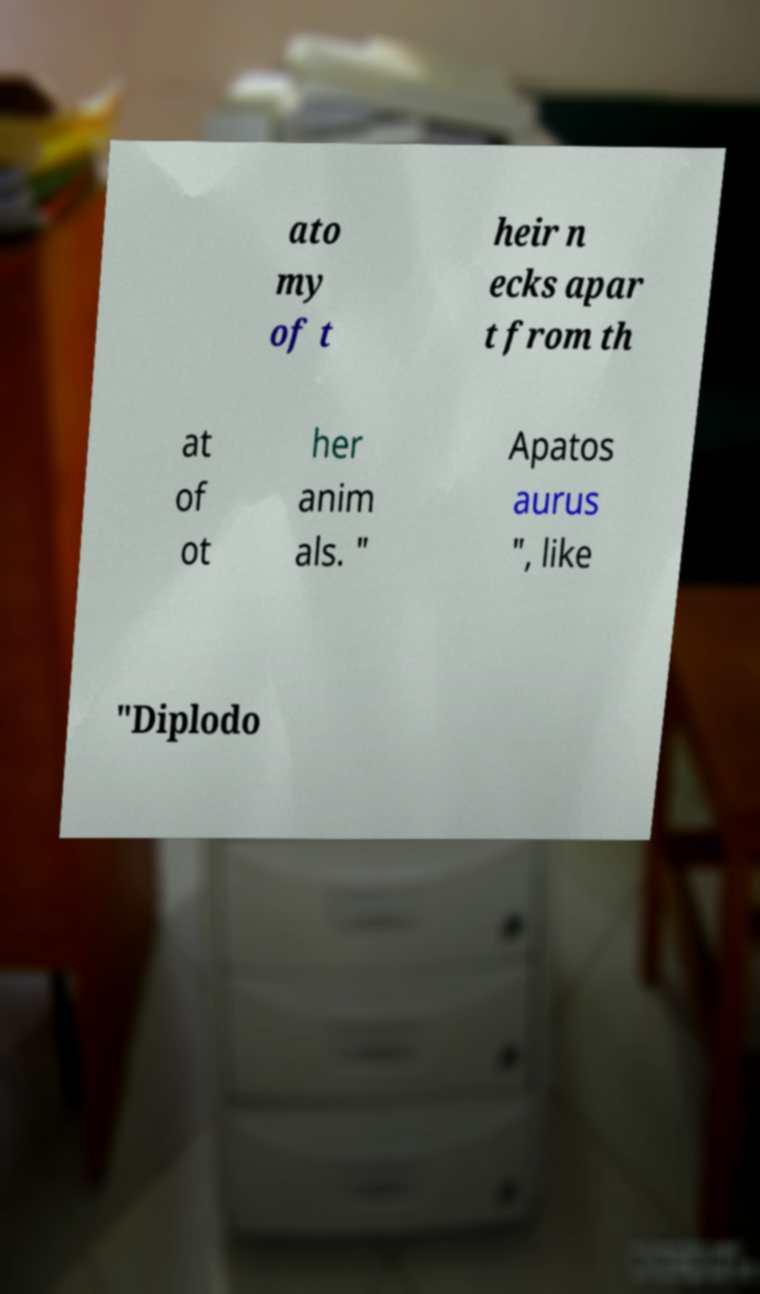Please read and relay the text visible in this image. What does it say? ato my of t heir n ecks apar t from th at of ot her anim als. " Apatos aurus ", like "Diplodo 